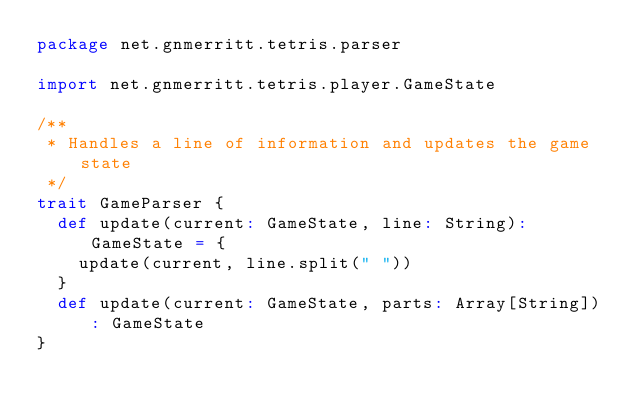<code> <loc_0><loc_0><loc_500><loc_500><_Scala_>package net.gnmerritt.tetris.parser

import net.gnmerritt.tetris.player.GameState

/**
 * Handles a line of information and updates the game state
 */
trait GameParser {
  def update(current: GameState, line: String): GameState = {
    update(current, line.split(" "))
  }
  def update(current: GameState, parts: Array[String]): GameState
}
</code> 